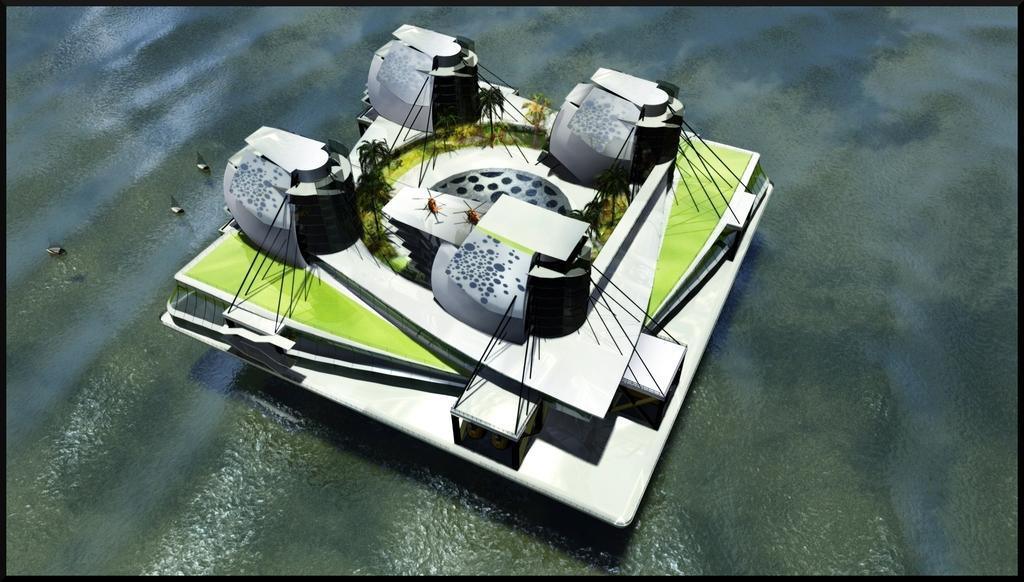Could you give a brief overview of what you see in this image? This is an animated image where there is a building, trees, planes, water and boats. 